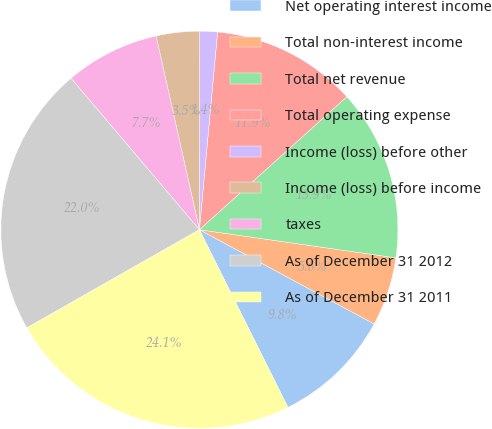<chart> <loc_0><loc_0><loc_500><loc_500><pie_chart><fcel>Net operating interest income<fcel>Total non-interest income<fcel>Total net revenue<fcel>Total operating expense<fcel>Income (loss) before other<fcel>Income (loss) before income<fcel>taxes<fcel>As of December 31 2012<fcel>As of December 31 2011<nl><fcel>9.77%<fcel>5.61%<fcel>13.94%<fcel>11.86%<fcel>1.44%<fcel>3.52%<fcel>7.69%<fcel>22.04%<fcel>24.12%<nl></chart> 